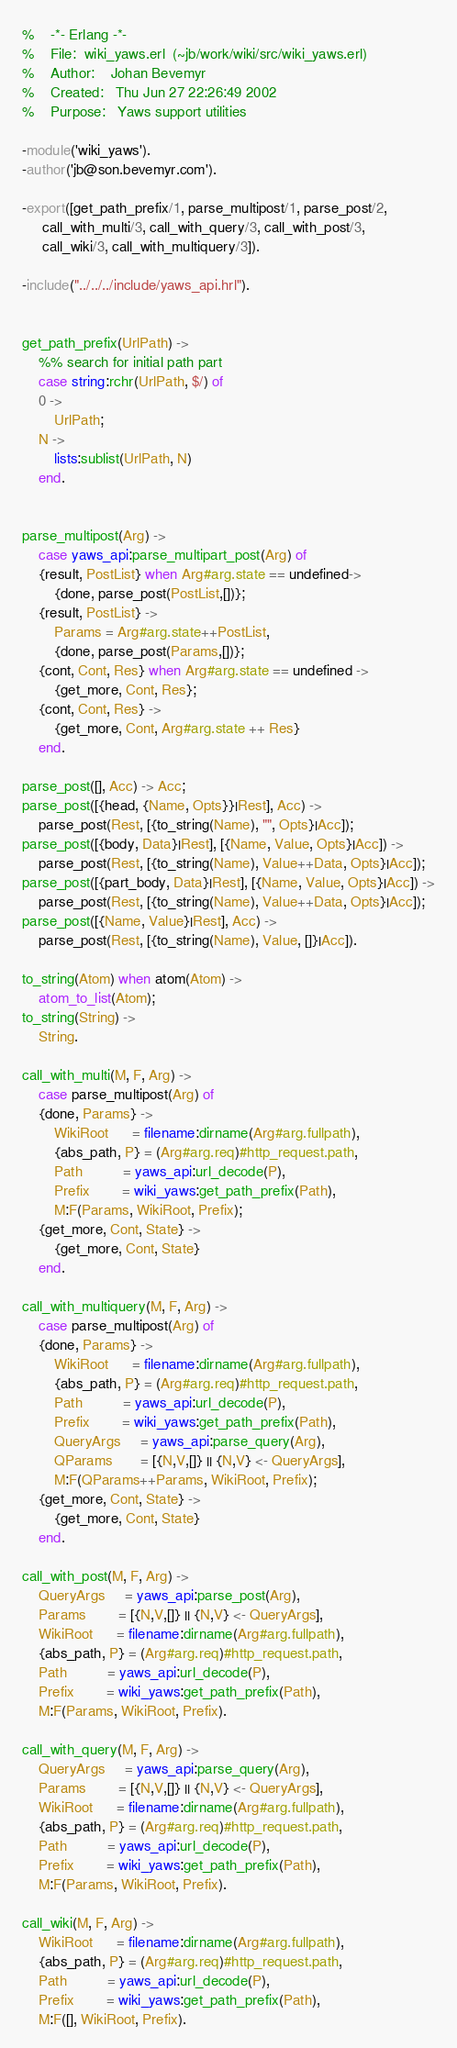<code> <loc_0><loc_0><loc_500><loc_500><_Erlang_>%    -*- Erlang -*- 
%    File:	wiki_yaws.erl  (~jb/work/wiki/src/wiki_yaws.erl)
%    Author:	Johan Bevemyr
%    Created:	Thu Jun 27 22:26:49 2002
%    Purpose:   Yaws support utilities

-module('wiki_yaws').
-author('jb@son.bevemyr.com').

-export([get_path_prefix/1, parse_multipost/1, parse_post/2,
	 call_with_multi/3, call_with_query/3, call_with_post/3,
	 call_wiki/3, call_with_multiquery/3]).

-include("../../../include/yaws_api.hrl").


get_path_prefix(UrlPath) ->
    %% search for initial path part
    case string:rchr(UrlPath, $/) of
	0 ->
	    UrlPath;
	N ->
	    lists:sublist(UrlPath, N)
    end.

 
parse_multipost(Arg) ->
    case yaws_api:parse_multipart_post(Arg) of
	{result, PostList} when Arg#arg.state == undefined->
	    {done, parse_post(PostList,[])};
	{result, PostList} ->
	    Params = Arg#arg.state++PostList,
	    {done, parse_post(Params,[])};
	{cont, Cont, Res} when Arg#arg.state == undefined ->
	    {get_more, Cont, Res};
	{cont, Cont, Res} ->
	    {get_more, Cont, Arg#arg.state ++ Res}
    end.

parse_post([], Acc) -> Acc;
parse_post([{head, {Name, Opts}}|Rest], Acc) ->
    parse_post(Rest, [{to_string(Name), "", Opts}|Acc]);
parse_post([{body, Data}|Rest], [{Name, Value, Opts}|Acc]) ->
    parse_post(Rest, [{to_string(Name), Value++Data, Opts}|Acc]);
parse_post([{part_body, Data}|Rest], [{Name, Value, Opts}|Acc]) ->
    parse_post(Rest, [{to_string(Name), Value++Data, Opts}|Acc]);
parse_post([{Name, Value}|Rest], Acc) ->
    parse_post(Rest, [{to_string(Name), Value, []}|Acc]).

to_string(Atom) when atom(Atom) ->
    atom_to_list(Atom);
to_string(String) ->
    String.

call_with_multi(M, F, Arg) ->
    case parse_multipost(Arg) of
	{done, Params} ->
	    WikiRoot      = filename:dirname(Arg#arg.fullpath),
	    {abs_path, P} = (Arg#arg.req)#http_request.path,
	    Path          = yaws_api:url_decode(P),
	    Prefix        = wiki_yaws:get_path_prefix(Path),
	    M:F(Params, WikiRoot, Prefix);
	{get_more, Cont, State} ->
	    {get_more, Cont, State}
    end.

call_with_multiquery(M, F, Arg) ->
    case parse_multipost(Arg) of
	{done, Params} ->
	    WikiRoot      = filename:dirname(Arg#arg.fullpath),
	    {abs_path, P} = (Arg#arg.req)#http_request.path,
	    Path          = yaws_api:url_decode(P),
	    Prefix        = wiki_yaws:get_path_prefix(Path),
	    QueryArgs     = yaws_api:parse_query(Arg),
	    QParams       = [{N,V,[]} || {N,V} <- QueryArgs],
	    M:F(QParams++Params, WikiRoot, Prefix);
	{get_more, Cont, State} ->
	    {get_more, Cont, State}
    end.

call_with_post(M, F, Arg) ->
    QueryArgs     = yaws_api:parse_post(Arg),
    Params        = [{N,V,[]} || {N,V} <- QueryArgs],
    WikiRoot      = filename:dirname(Arg#arg.fullpath),
    {abs_path, P} = (Arg#arg.req)#http_request.path,
    Path          = yaws_api:url_decode(P),
    Prefix        = wiki_yaws:get_path_prefix(Path),
    M:F(Params, WikiRoot, Prefix).

call_with_query(M, F, Arg) ->
    QueryArgs     = yaws_api:parse_query(Arg),
    Params        = [{N,V,[]} || {N,V} <- QueryArgs],
    WikiRoot      = filename:dirname(Arg#arg.fullpath),
    {abs_path, P} = (Arg#arg.req)#http_request.path,
    Path          = yaws_api:url_decode(P),
    Prefix        = wiki_yaws:get_path_prefix(Path),
    M:F(Params, WikiRoot, Prefix).

call_wiki(M, F, Arg) ->
    WikiRoot      = filename:dirname(Arg#arg.fullpath),
    {abs_path, P} = (Arg#arg.req)#http_request.path,
    Path          = yaws_api:url_decode(P),
    Prefix        = wiki_yaws:get_path_prefix(Path),
    M:F([], WikiRoot, Prefix).
</code> 